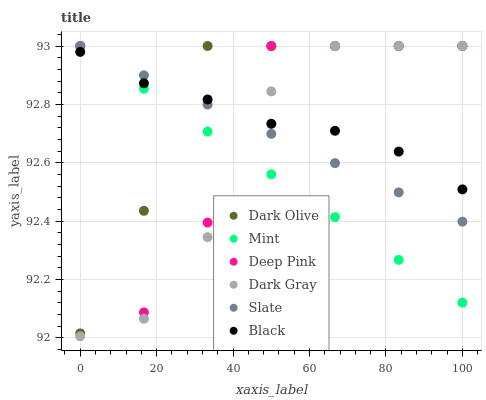Does Mint have the minimum area under the curve?
Answer yes or no. Yes. Does Dark Olive have the maximum area under the curve?
Answer yes or no. Yes. Does Slate have the minimum area under the curve?
Answer yes or no. No. Does Slate have the maximum area under the curve?
Answer yes or no. No. Is Slate the smoothest?
Answer yes or no. Yes. Is Deep Pink the roughest?
Answer yes or no. Yes. Is Dark Olive the smoothest?
Answer yes or no. No. Is Dark Olive the roughest?
Answer yes or no. No. Does Dark Gray have the lowest value?
Answer yes or no. Yes. Does Slate have the lowest value?
Answer yes or no. No. Does Mint have the highest value?
Answer yes or no. Yes. Does Black have the highest value?
Answer yes or no. No. Does Black intersect Slate?
Answer yes or no. Yes. Is Black less than Slate?
Answer yes or no. No. Is Black greater than Slate?
Answer yes or no. No. 